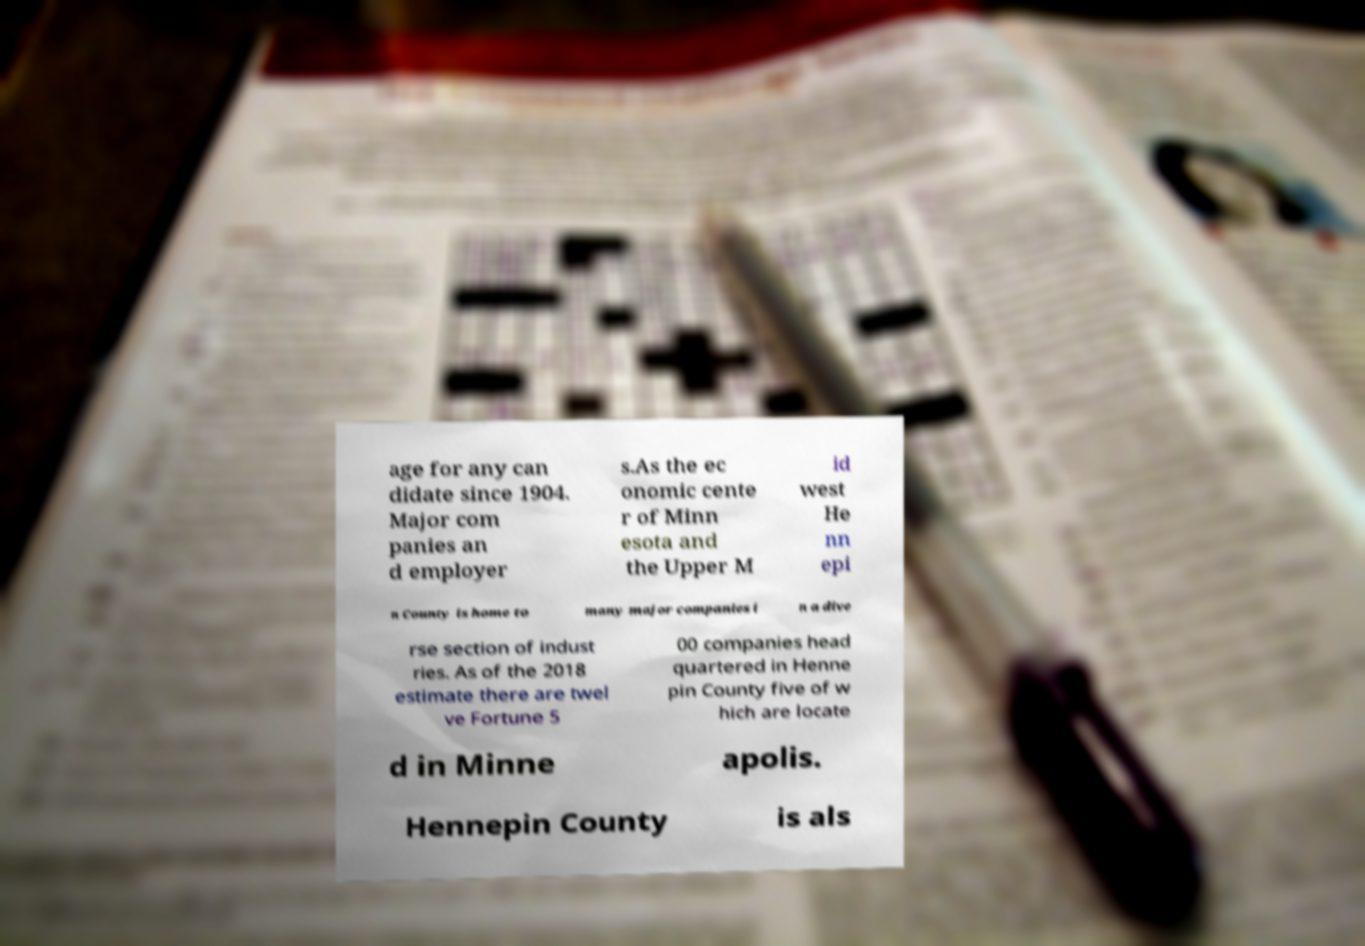There's text embedded in this image that I need extracted. Can you transcribe it verbatim? age for any can didate since 1904. Major com panies an d employer s.As the ec onomic cente r of Minn esota and the Upper M id west He nn epi n County is home to many major companies i n a dive rse section of indust ries. As of the 2018 estimate there are twel ve Fortune 5 00 companies head quartered in Henne pin County five of w hich are locate d in Minne apolis. Hennepin County is als 